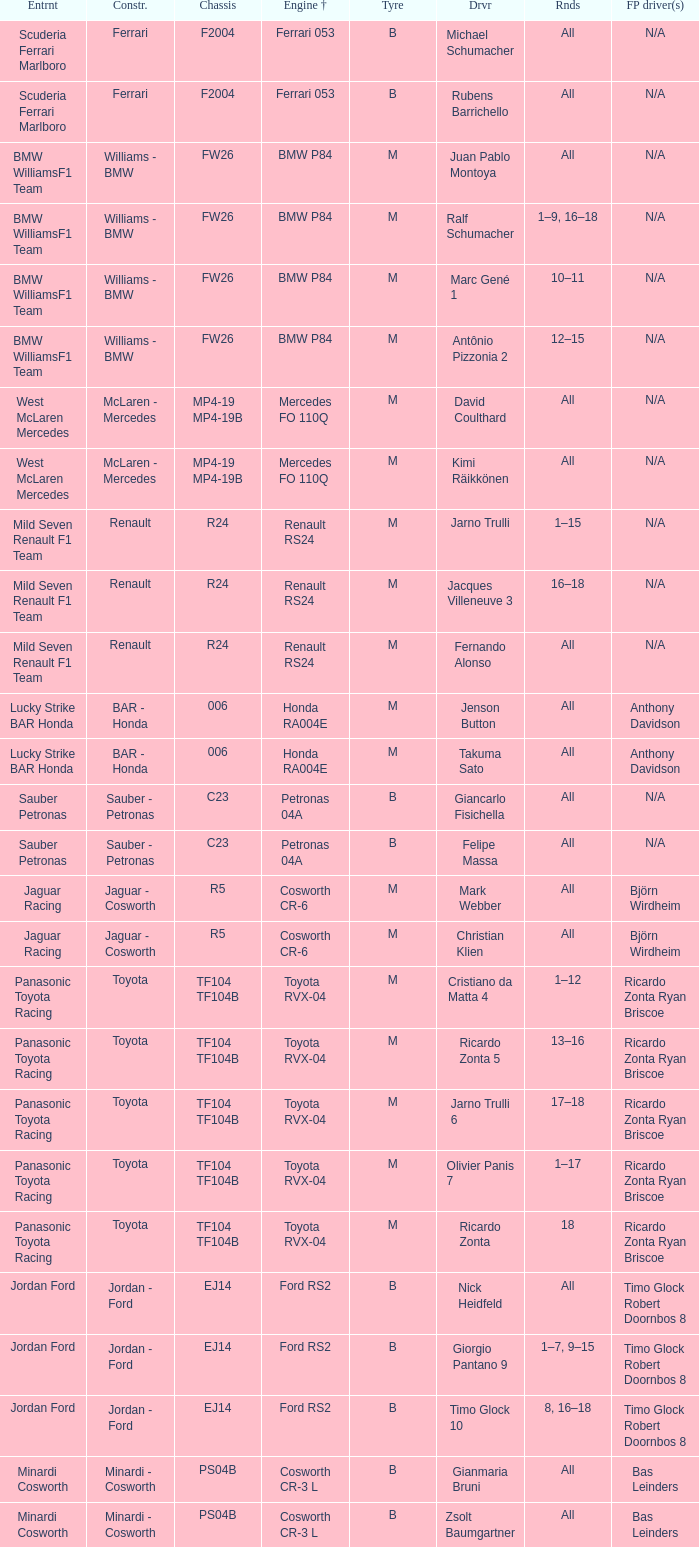What are the rounds for the B tyres and Ferrari 053 engine +? All, All. Can you give me this table as a dict? {'header': ['Entrnt', 'Constr.', 'Chassis', 'Engine †', 'Tyre', 'Drvr', 'Rnds', 'FP driver(s)'], 'rows': [['Scuderia Ferrari Marlboro', 'Ferrari', 'F2004', 'Ferrari 053', 'B', 'Michael Schumacher', 'All', 'N/A'], ['Scuderia Ferrari Marlboro', 'Ferrari', 'F2004', 'Ferrari 053', 'B', 'Rubens Barrichello', 'All', 'N/A'], ['BMW WilliamsF1 Team', 'Williams - BMW', 'FW26', 'BMW P84', 'M', 'Juan Pablo Montoya', 'All', 'N/A'], ['BMW WilliamsF1 Team', 'Williams - BMW', 'FW26', 'BMW P84', 'M', 'Ralf Schumacher', '1–9, 16–18', 'N/A'], ['BMW WilliamsF1 Team', 'Williams - BMW', 'FW26', 'BMW P84', 'M', 'Marc Gené 1', '10–11', 'N/A'], ['BMW WilliamsF1 Team', 'Williams - BMW', 'FW26', 'BMW P84', 'M', 'Antônio Pizzonia 2', '12–15', 'N/A'], ['West McLaren Mercedes', 'McLaren - Mercedes', 'MP4-19 MP4-19B', 'Mercedes FO 110Q', 'M', 'David Coulthard', 'All', 'N/A'], ['West McLaren Mercedes', 'McLaren - Mercedes', 'MP4-19 MP4-19B', 'Mercedes FO 110Q', 'M', 'Kimi Räikkönen', 'All', 'N/A'], ['Mild Seven Renault F1 Team', 'Renault', 'R24', 'Renault RS24', 'M', 'Jarno Trulli', '1–15', 'N/A'], ['Mild Seven Renault F1 Team', 'Renault', 'R24', 'Renault RS24', 'M', 'Jacques Villeneuve 3', '16–18', 'N/A'], ['Mild Seven Renault F1 Team', 'Renault', 'R24', 'Renault RS24', 'M', 'Fernando Alonso', 'All', 'N/A'], ['Lucky Strike BAR Honda', 'BAR - Honda', '006', 'Honda RA004E', 'M', 'Jenson Button', 'All', 'Anthony Davidson'], ['Lucky Strike BAR Honda', 'BAR - Honda', '006', 'Honda RA004E', 'M', 'Takuma Sato', 'All', 'Anthony Davidson'], ['Sauber Petronas', 'Sauber - Petronas', 'C23', 'Petronas 04A', 'B', 'Giancarlo Fisichella', 'All', 'N/A'], ['Sauber Petronas', 'Sauber - Petronas', 'C23', 'Petronas 04A', 'B', 'Felipe Massa', 'All', 'N/A'], ['Jaguar Racing', 'Jaguar - Cosworth', 'R5', 'Cosworth CR-6', 'M', 'Mark Webber', 'All', 'Björn Wirdheim'], ['Jaguar Racing', 'Jaguar - Cosworth', 'R5', 'Cosworth CR-6', 'M', 'Christian Klien', 'All', 'Björn Wirdheim'], ['Panasonic Toyota Racing', 'Toyota', 'TF104 TF104B', 'Toyota RVX-04', 'M', 'Cristiano da Matta 4', '1–12', 'Ricardo Zonta Ryan Briscoe'], ['Panasonic Toyota Racing', 'Toyota', 'TF104 TF104B', 'Toyota RVX-04', 'M', 'Ricardo Zonta 5', '13–16', 'Ricardo Zonta Ryan Briscoe'], ['Panasonic Toyota Racing', 'Toyota', 'TF104 TF104B', 'Toyota RVX-04', 'M', 'Jarno Trulli 6', '17–18', 'Ricardo Zonta Ryan Briscoe'], ['Panasonic Toyota Racing', 'Toyota', 'TF104 TF104B', 'Toyota RVX-04', 'M', 'Olivier Panis 7', '1–17', 'Ricardo Zonta Ryan Briscoe'], ['Panasonic Toyota Racing', 'Toyota', 'TF104 TF104B', 'Toyota RVX-04', 'M', 'Ricardo Zonta', '18', 'Ricardo Zonta Ryan Briscoe'], ['Jordan Ford', 'Jordan - Ford', 'EJ14', 'Ford RS2', 'B', 'Nick Heidfeld', 'All', 'Timo Glock Robert Doornbos 8'], ['Jordan Ford', 'Jordan - Ford', 'EJ14', 'Ford RS2', 'B', 'Giorgio Pantano 9', '1–7, 9–15', 'Timo Glock Robert Doornbos 8'], ['Jordan Ford', 'Jordan - Ford', 'EJ14', 'Ford RS2', 'B', 'Timo Glock 10', '8, 16–18', 'Timo Glock Robert Doornbos 8'], ['Minardi Cosworth', 'Minardi - Cosworth', 'PS04B', 'Cosworth CR-3 L', 'B', 'Gianmaria Bruni', 'All', 'Bas Leinders'], ['Minardi Cosworth', 'Minardi - Cosworth', 'PS04B', 'Cosworth CR-3 L', 'B', 'Zsolt Baumgartner', 'All', 'Bas Leinders']]} 